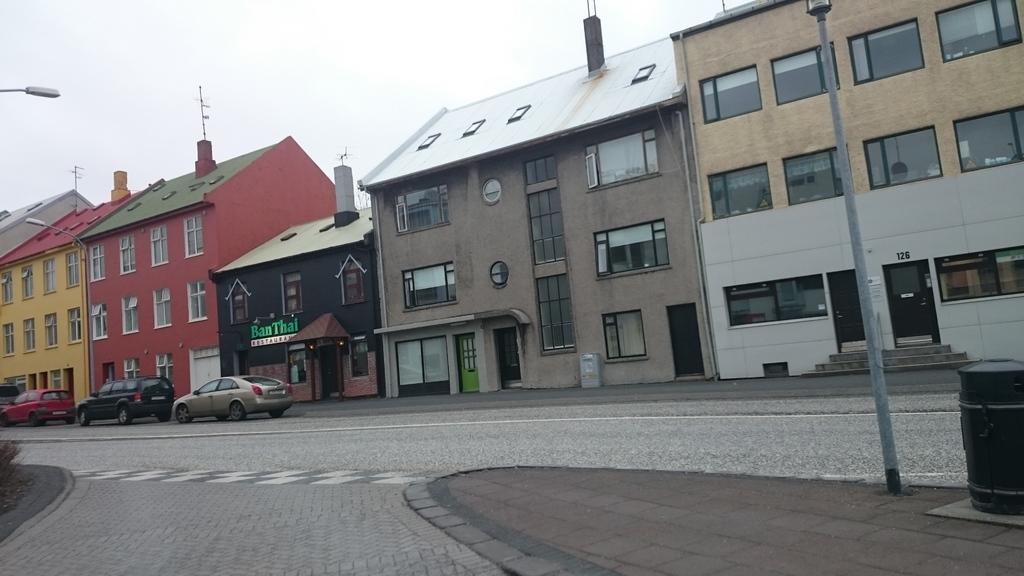What type of structures can be seen in the image? There are buildings in the image. What is happening on the road in the image? There are vehicles on the road in the image. What is used to illuminate the road at night in the image? Street lights are present in the image. What is located on the pavement in the image? There is a bin on the pavement in the image. What type of vegetation is visible in the image? Grass is visible in the image. What is visible above the buildings and vehicles in the image? The sky is visible in the image. What type of root can be seen growing from the bin in the image? There is no root growing from the bin in the image; it is a stationary object. What type of food is being served at the restaurant in the image? There is no restaurant or food visible in the image. 